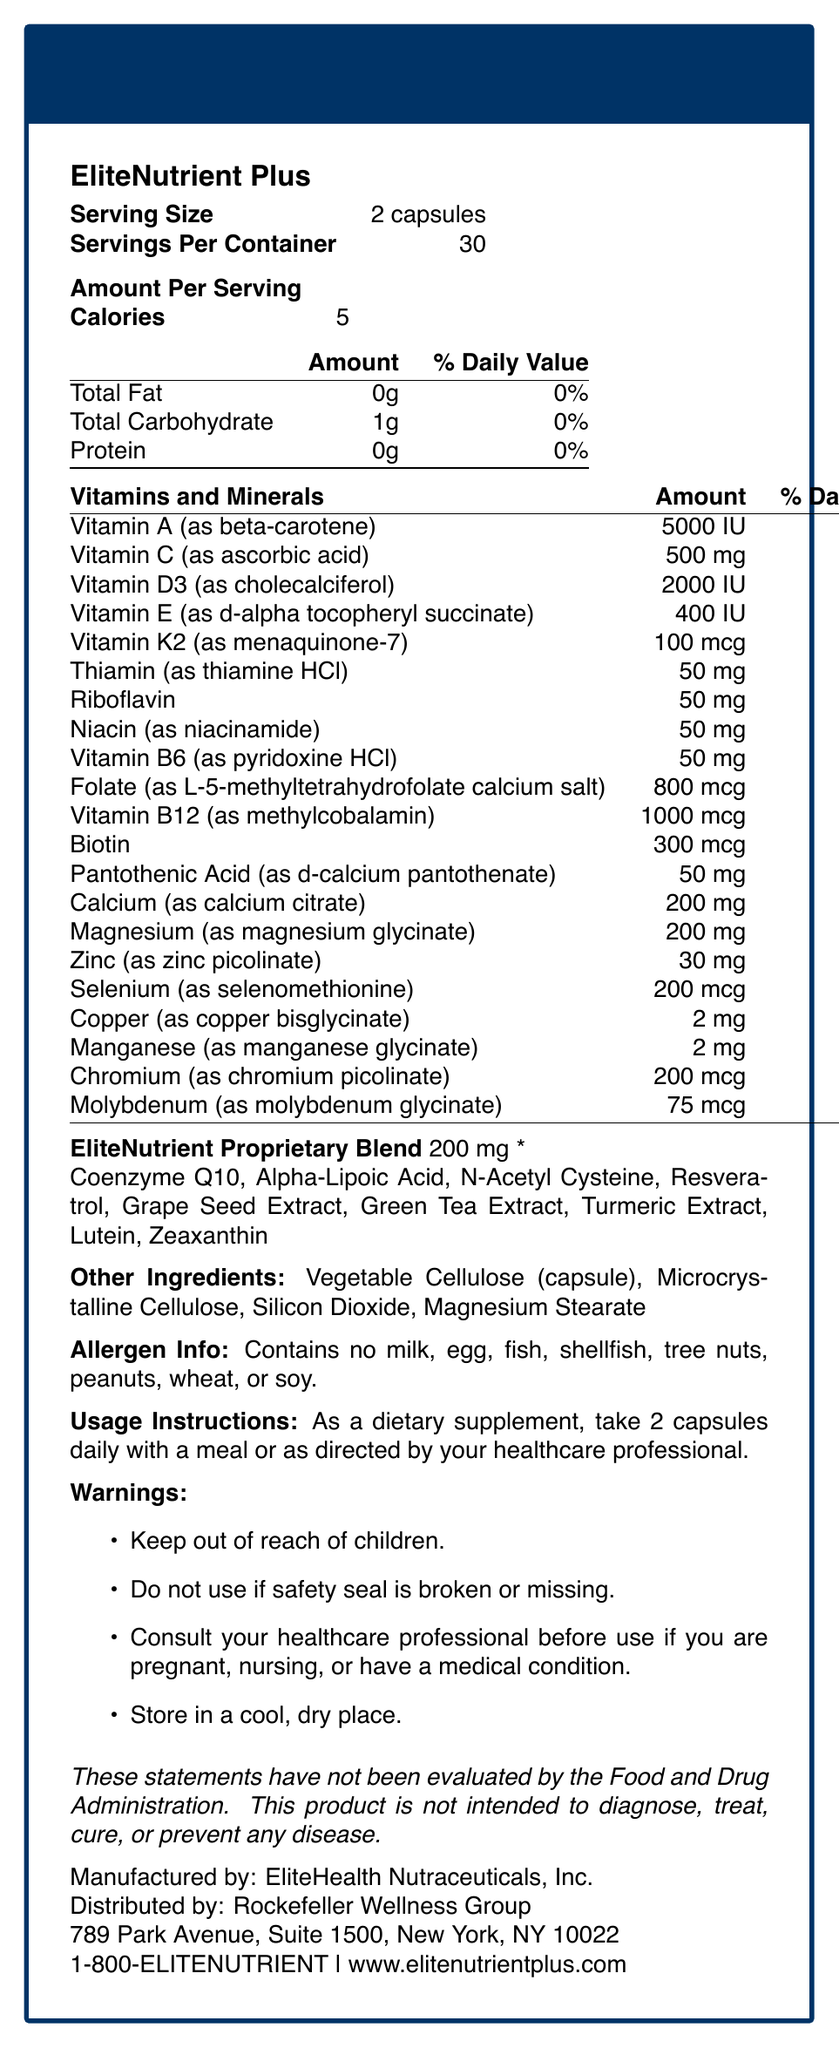What is the serving size of EliteNutrient Plus? The serving size is explicitly stated as "2 capsules" within the document.
Answer: 2 capsules How many servings are there per container? The document mentions that there are 30 servings per container.
Answer: 30 How many calories are there per serving? The document states "Calories: 5" per serving.
Answer: 5 What is the total carbohydrate content per serving? The document specifies that the total carbohydrate content per serving is 1g.
Answer: 1g Which vitamin is present in the highest percent daily value? Vitamin B12 has a daily value of 16,667%, the highest among all the listed vitamins and minerals.
Answer: Vitamin B12 (as methylcobalamin) What is the form of Vitamin D in EliteNutrient Plus? According to the document, the form of Vitamin D in EliteNutrient Plus is Vitamin D3 (as cholecalciferol).
Answer: Vitamin D3 (as cholecalciferol) What is the percentage daily value of Selenium in this supplement? The document provides the amount as 200 mcg, which corresponds to 286% of the daily value for Selenium.
Answer: 286% What ingredients are included in the EliteNutrient Proprietary Blend? A. Coenzyme Q10, Lutein, Vitamin A B. Alpha-Lipoic Acid, Lycopene, Resveratrol C. N-Acetyl Cysteine, Green Tea Extract, Turmeric Extract D. Zinc, Vitamin C, Copper The EliteNutrient Proprietary Blend includes Coenzyme Q10, Alpha-Lipoic Acid, N-Acetyl Cysteine, Resveratrol, Grape Seed Extract, Green Tea Extract, Turmeric Extract, Lutein, and Zeaxanthin.
Answer: C Which type of ingredient is not included in the 'Other Ingredients' list? A. Vegetable Cellulose B. Microcrystalline Cellulose C. Silicon Dioxide D. Magnesium Silicate The 'Other Ingredients' list includes Vegetable Cellulose, Microcrystalline Cellulose, Silicon Dioxide, and Magnesium Stearate, but not Magnesium Silicate.
Answer: D Does EliteNutrient Plus contain any common allergens such as milk or soy? The allergen information specifies that the product contains no milk, egg, fish, shellfish, tree nuts, peanuts, wheat, or soy.
Answer: No Summarize the main idea of the document. The document outlines everything a consumer would need to know about EliteNutrient Plus, including what’s in it, how to use it, and important safety and contact information.
Answer: The document provides a comprehensive overview of the nutritional information for EliteNutrient Plus, a premium multivitamin supplement. It covers serving size, calorie count, detailed vitamin and mineral content with their respective daily values, the ingredients in the proprietary blend, other ingredients, allergen information, usage instructions, warnings, and contact information for the manufacturer and distributor. What is the daily value percentage of Vitamin A present in EliteNutrient Plus? The document clearly states that Vitamin A has a daily value of 100%.
Answer: 100% Can you take EliteNutrient Plus if you are pregnant without consulting a healthcare professional? The warnings section advises consulting a healthcare professional before use if you are pregnant.
Answer: No How should EliteNutrient Plus be stored? The document instructs users to store the product in a cool, dry place.
Answer: In a cool, dry place What is the proprietary blend amount per serving? It is mentioned in the document that the EliteNutrient Proprietary Blend amounts to 200 mg per serving.
Answer: 200 mg When is the best time to take EliteNutrient Plus capsules? The usage instructions recommend taking 2 capsules daily with a meal or as directed by a healthcare professional.
Answer: With a meal or as directed by a healthcare professional What is the phone number for contacting EliteHealth Nutraceuticals, Inc.? The contact information section provides the phone number for contacting EliteHealth Nutraceuticals, Inc.
Answer: 1-800-ELITENUTRIENT What is the relationship between EliteHealth Nutraceuticals, Inc. and Rockefeller Wellness Group? The document specifies that EliteHealth Nutraceuticals, Inc. is the manufacturer, while Rockefeller Wellness Group is the distributor.
Answer: EliteHealth Nutraceuticals, Inc. is the manufacturer, and Rockefeller Wellness Group is the distributor. What kind of professional title should consult the supplement use if someone has a medical condition? The warnings advise consulting a healthcare professional if you have a medical condition before using the supplement.
Answer: Healthcare professional Does the document provide information about the microelement content such as Iron? The document does not mention Iron or its content as part of the vitamins and minerals listed.
Answer: No 